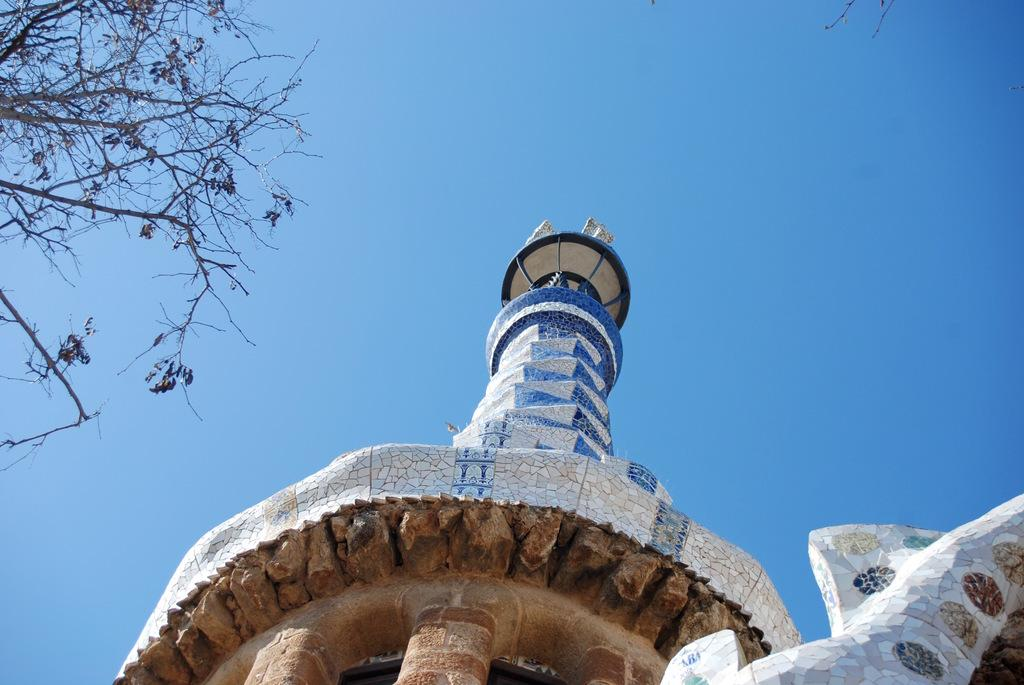What is the main structure in the image? There is a tower in the image. What type of vegetation is on the left side of the image? There is a tree on the left side of the image. What can be seen in the background of the image? The sky is visible in the background of the image. What type of pet can be seen playing with smoke in the image? There is no pet or smoke present in the image. 